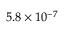<formula> <loc_0><loc_0><loc_500><loc_500>5 . 8 \times 1 0 ^ { - 7 }</formula> 